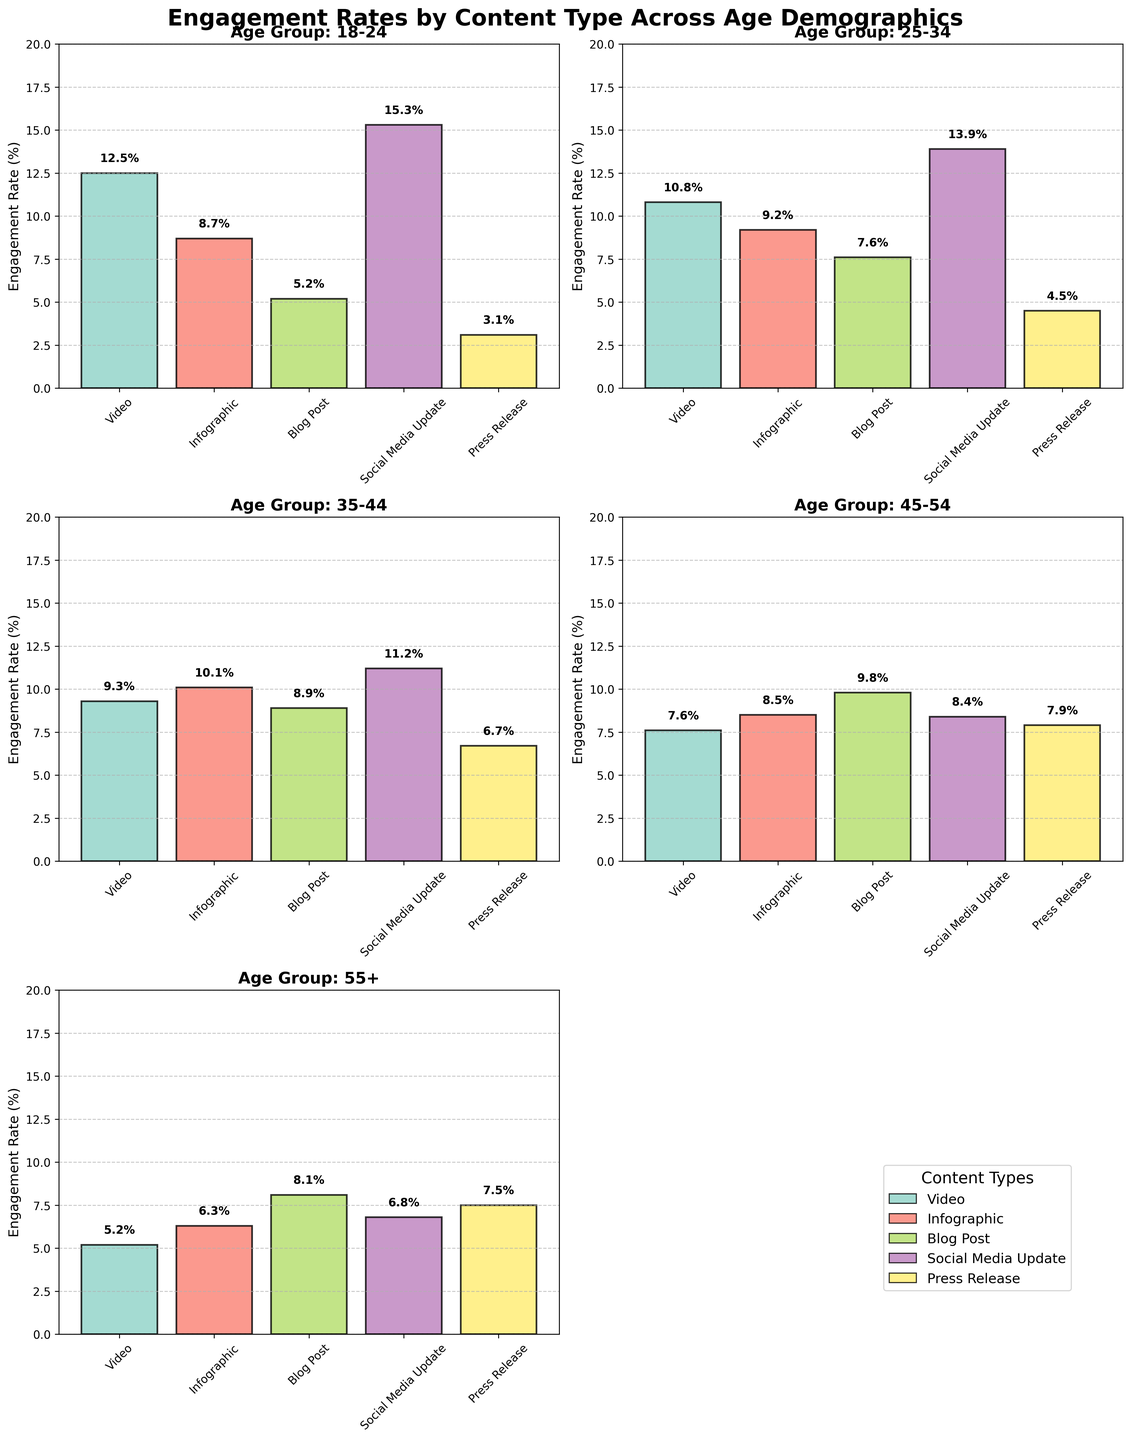What age group has the highest engagement rate for Social Media Updates? In the subplot for each age group, the bar height represents the engagement rate. For Social Media Updates, the highest bar among the age groups can be observed in the 18-24 category at 15.3%.
Answer: 18-24 Which content type shows the highest engagement rate for the 25-34 age group? Examine the subplot for the 25-34 age group and compare the heights of the bars. The bar for Social Media Update is the tallest, indicating it has the highest engagement rate at 13.9%.
Answer: Social Media Update What is the engagement rate for blog posts in the 35-44 age group? Look at the subplot for the 35-44 age group and find the bar labeled "Blog Post." The height of this bar is 8.9%.
Answer: 8.9% Which age group has the lowest engagement rate for videos? Compare the heights of the "Video" bars across all age group subplots. The smallest bar corresponds to the 55+ age group, with an engagement rate of 5.2%.
Answer: 55+ What is the total engagement rate for Infographics across all age groups? To find the total, add up the engagement rates for Infographics in each age group: 8.7 (18-24) + 9.2 (25-34) + 10.1 (35-44) + 8.5 (45-54) + 6.3 (55+) = 42.8%.
Answer: 42.8% What is the difference in engagement rates for Press Releases between the 45-54 and 55+ age groups? Refer to the subplots for the 45-54 and 55+ age groups. The engagement rates for Press Releases are 7.9% and 7.5%, respectively. The difference is 7.9% - 7.5% = 0.4%.
Answer: 0.4% How does the engagement rate for Blog Posts in the 18-24 age group compare to that in the 45-54 age group? Examine the bars for Blog Posts in the subplots for the 18-24 and 45-54 age groups. The engagement rates are 5.2% and 9.8%, respectively. The 45-54 age group has a higher engagement rate.
Answer: 45-54 has a higher rate What is the average engagement rate for Social Media Updates across all age groups? Add the engagement rates for Social Media Updates in all age groups and divide by the number of age groups: (15.3 + 13.9 + 11.2 + 8.4 + 6.8) / 5 = 11.12%.
Answer: 11.1% (rounded) Which content type has the most consistent (smallest range) engagement rates across all age groups? Calculate the range (max - min) for each content type across age groups. The ranges are: Video (12.5 - 5.2 = 7.3), Infographic (10.1 - 6.3 = 3.8), Blog Post (9.8 - 5.2 = 4.6), Social Media Update (15.3 - 6.8 = 8.5), Press Release (7.9 - 3.1 = 4.8). Infographic has the smallest range.
Answer: Infographic Which age group has the most diverse engagement rates across content types? Calculate the range for engagement rates within each age group: 18-24 (15.3 - 3.1 = 12.2), 25-34 (13.9 - 4.5 = 9.4), 35-44 (11.2 - 6.7 = 4.5), 45-54 (9.8 - 7.6 = 2.2), 55+ (8.1 - 5.2 = 2.9). The 18-24 age group has the highest range.
Answer: 18-24 